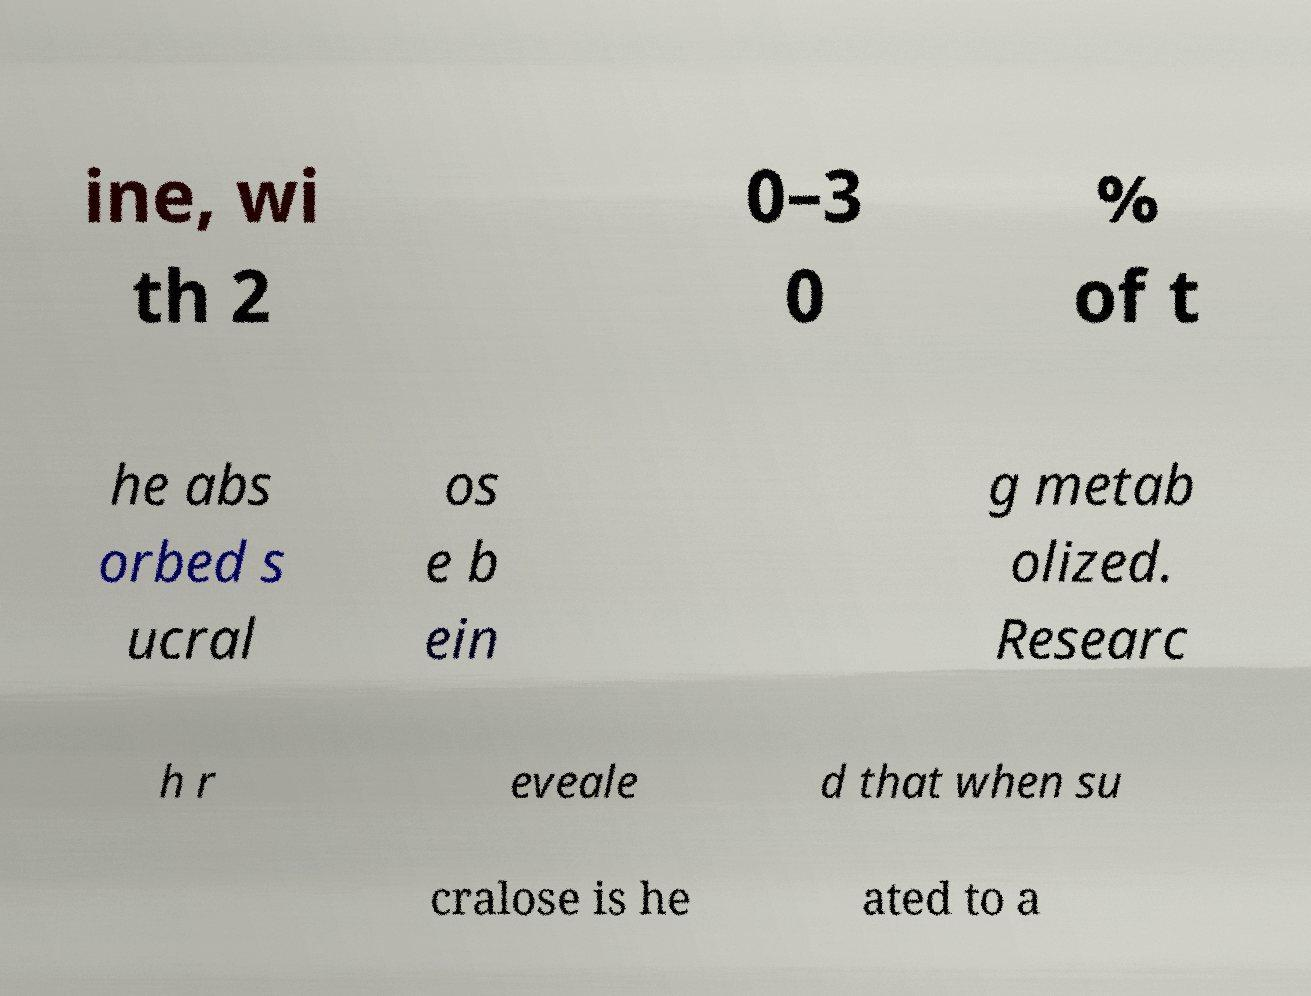Can you accurately transcribe the text from the provided image for me? ine, wi th 2 0–3 0 % of t he abs orbed s ucral os e b ein g metab olized. Researc h r eveale d that when su cralose is he ated to a 